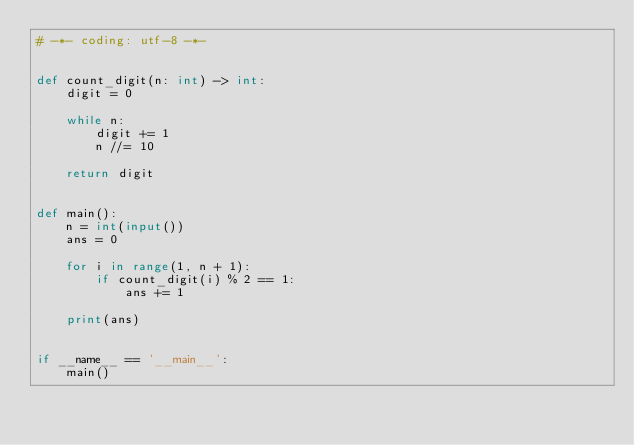Convert code to text. <code><loc_0><loc_0><loc_500><loc_500><_Python_># -*- coding: utf-8 -*-


def count_digit(n: int) -> int:
    digit = 0

    while n:
        digit += 1
        n //= 10

    return digit


def main():
    n = int(input())
    ans = 0

    for i in range(1, n + 1):
        if count_digit(i) % 2 == 1:
            ans += 1

    print(ans)


if __name__ == '__main__':
    main()
</code> 